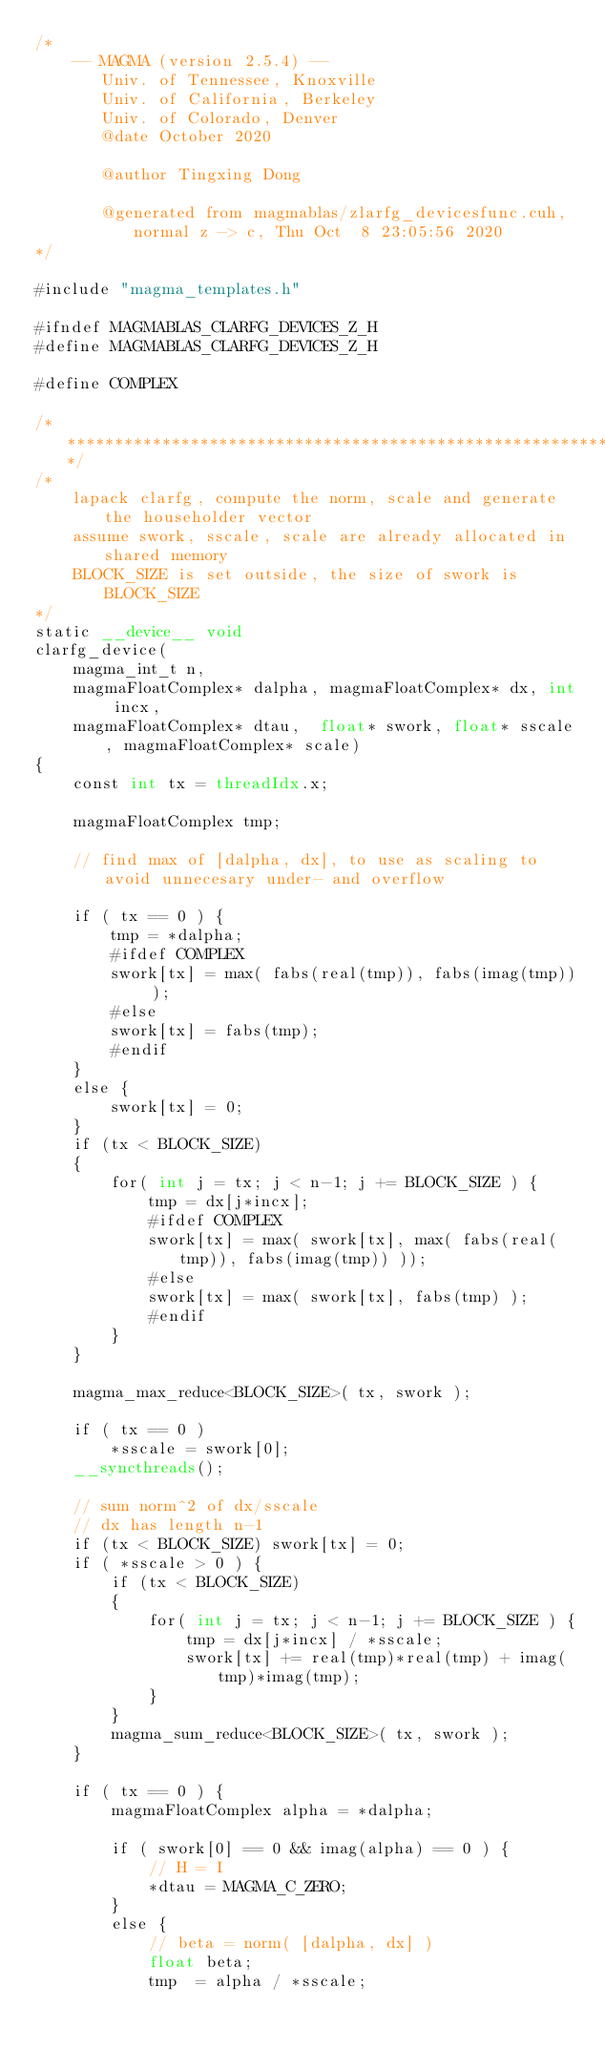<code> <loc_0><loc_0><loc_500><loc_500><_Cuda_>/*
    -- MAGMA (version 2.5.4) --
       Univ. of Tennessee, Knoxville
       Univ. of California, Berkeley
       Univ. of Colorado, Denver
       @date October 2020

       @author Tingxing Dong

       @generated from magmablas/zlarfg_devicesfunc.cuh, normal z -> c, Thu Oct  8 23:05:56 2020
*/

#include "magma_templates.h"

#ifndef MAGMABLAS_CLARFG_DEVICES_Z_H
#define MAGMABLAS_CLARFG_DEVICES_Z_H

#define COMPLEX

/******************************************************************************/
/*
    lapack clarfg, compute the norm, scale and generate the householder vector   
    assume swork, sscale, scale are already allocated in shared memory
    BLOCK_SIZE is set outside, the size of swork is BLOCK_SIZE
*/
static __device__ void
clarfg_device(
    magma_int_t n,
    magmaFloatComplex* dalpha, magmaFloatComplex* dx, int incx,
    magmaFloatComplex* dtau,  float* swork, float* sscale, magmaFloatComplex* scale)
{
    const int tx = threadIdx.x;

    magmaFloatComplex tmp;
    
    // find max of [dalpha, dx], to use as scaling to avoid unnecesary under- and overflow    

    if ( tx == 0 ) {
        tmp = *dalpha;
        #ifdef COMPLEX
        swork[tx] = max( fabs(real(tmp)), fabs(imag(tmp)) );
        #else
        swork[tx] = fabs(tmp);
        #endif
    }
    else {
        swork[tx] = 0;
    }
    if (tx < BLOCK_SIZE)
    {
        for( int j = tx; j < n-1; j += BLOCK_SIZE ) {
            tmp = dx[j*incx];
            #ifdef COMPLEX
            swork[tx] = max( swork[tx], max( fabs(real(tmp)), fabs(imag(tmp)) ));
            #else
            swork[tx] = max( swork[tx], fabs(tmp) );
            #endif
        }
    }

    magma_max_reduce<BLOCK_SIZE>( tx, swork );

    if ( tx == 0 )
        *sscale = swork[0];
    __syncthreads();
    
    // sum norm^2 of dx/sscale
    // dx has length n-1
    if (tx < BLOCK_SIZE) swork[tx] = 0;
    if ( *sscale > 0 ) {
        if (tx < BLOCK_SIZE)
        {
            for( int j = tx; j < n-1; j += BLOCK_SIZE ) {
                tmp = dx[j*incx] / *sscale;
                swork[tx] += real(tmp)*real(tmp) + imag(tmp)*imag(tmp);
            }
        }
        magma_sum_reduce<BLOCK_SIZE>( tx, swork );
    }
    
    if ( tx == 0 ) {
        magmaFloatComplex alpha = *dalpha;

        if ( swork[0] == 0 && imag(alpha) == 0 ) {
            // H = I
            *dtau = MAGMA_C_ZERO;
        }
        else {
            // beta = norm( [dalpha, dx] )
            float beta;
            tmp  = alpha / *sscale;</code> 